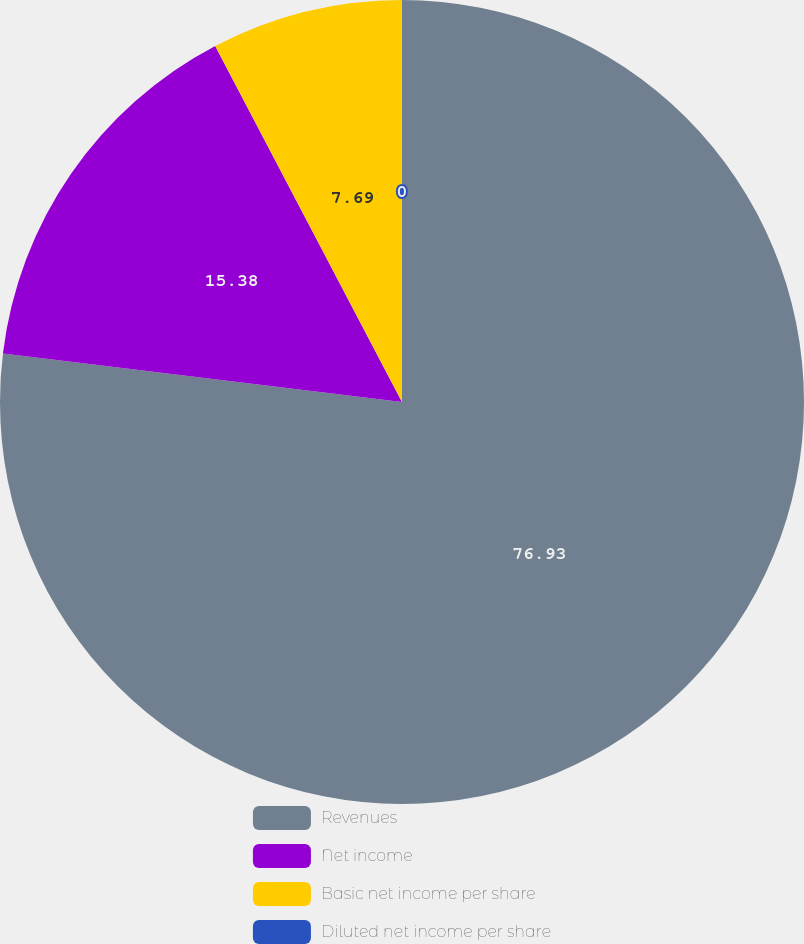Convert chart to OTSL. <chart><loc_0><loc_0><loc_500><loc_500><pie_chart><fcel>Revenues<fcel>Net income<fcel>Basic net income per share<fcel>Diluted net income per share<nl><fcel>76.92%<fcel>15.38%<fcel>7.69%<fcel>0.0%<nl></chart> 